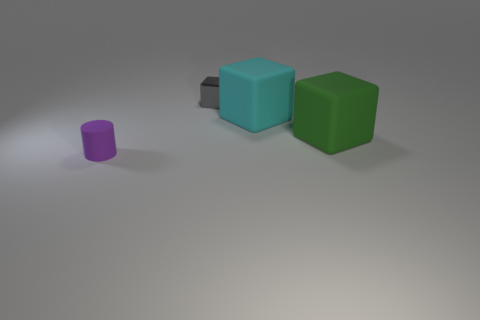Add 3 green metallic cylinders. How many objects exist? 7 Subtract all cylinders. How many objects are left? 3 Add 4 large green matte things. How many large green matte things exist? 5 Subtract 0 blue blocks. How many objects are left? 4 Subtract all big blue metallic objects. Subtract all large green matte cubes. How many objects are left? 3 Add 2 matte things. How many matte things are left? 5 